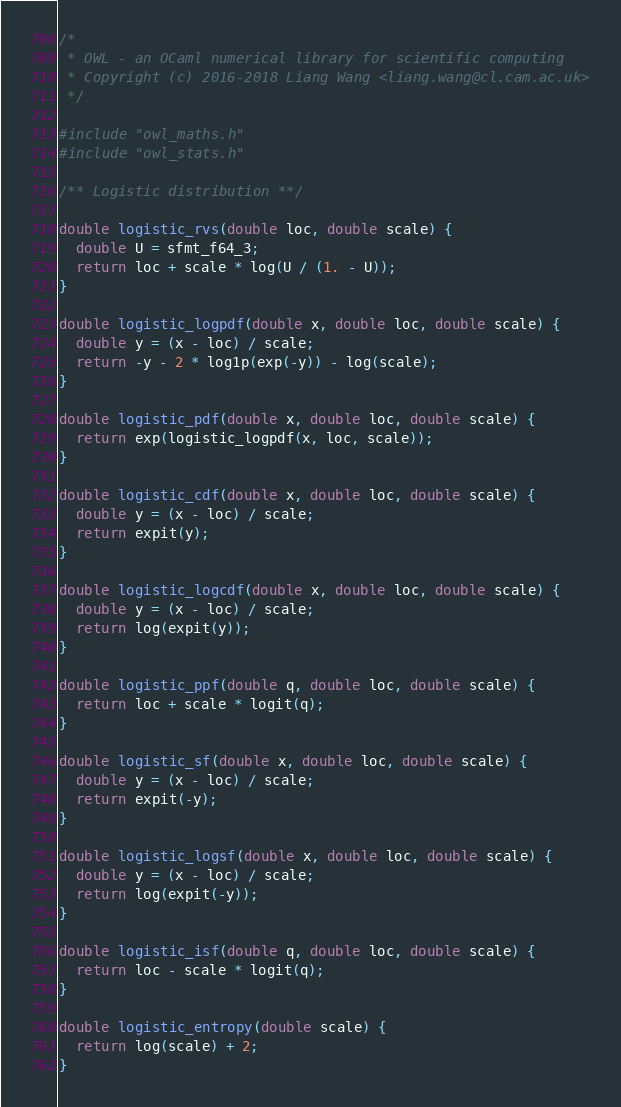<code> <loc_0><loc_0><loc_500><loc_500><_C_>/*
 * OWL - an OCaml numerical library for scientific computing
 * Copyright (c) 2016-2018 Liang Wang <liang.wang@cl.cam.ac.uk>
 */

#include "owl_maths.h"
#include "owl_stats.h"

/** Logistic distribution **/

double logistic_rvs(double loc, double scale) {
  double U = sfmt_f64_3;
  return loc + scale * log(U / (1. - U));
}

double logistic_logpdf(double x, double loc, double scale) {
  double y = (x - loc) / scale;
  return -y - 2 * log1p(exp(-y)) - log(scale);
}

double logistic_pdf(double x, double loc, double scale) {
  return exp(logistic_logpdf(x, loc, scale));
}

double logistic_cdf(double x, double loc, double scale) {
  double y = (x - loc) / scale;
  return expit(y);
}

double logistic_logcdf(double x, double loc, double scale) {
  double y = (x - loc) / scale;
  return log(expit(y));
}

double logistic_ppf(double q, double loc, double scale) {
  return loc + scale * logit(q);
}

double logistic_sf(double x, double loc, double scale) {
  double y = (x - loc) / scale;
  return expit(-y);
}

double logistic_logsf(double x, double loc, double scale) {
  double y = (x - loc) / scale;
  return log(expit(-y));
}

double logistic_isf(double q, double loc, double scale) {
  return loc - scale * logit(q);
}

double logistic_entropy(double scale) {
  return log(scale) + 2;
}
</code> 